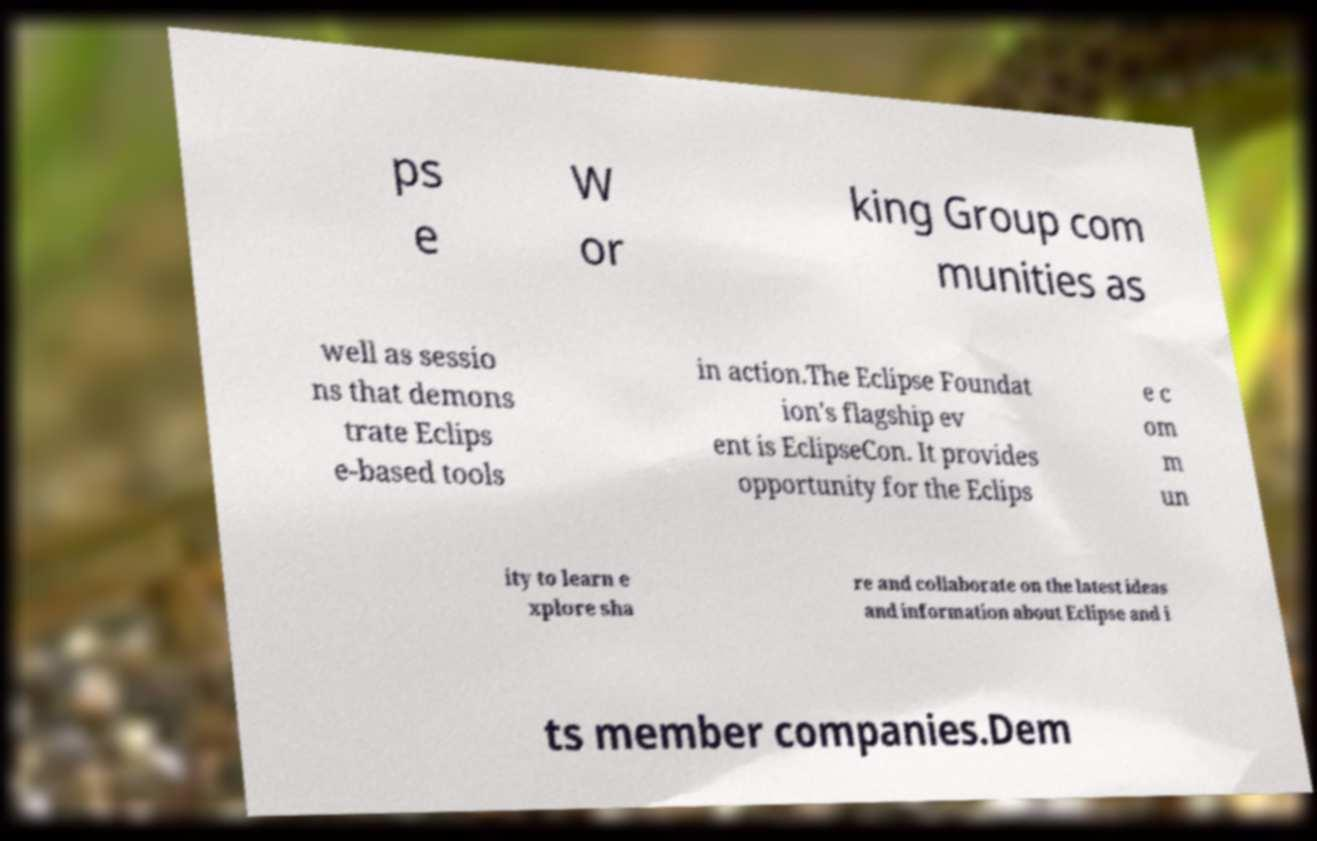For documentation purposes, I need the text within this image transcribed. Could you provide that? ps e W or king Group com munities as well as sessio ns that demons trate Eclips e-based tools in action.The Eclipse Foundat ion's flagship ev ent is EclipseCon. It provides opportunity for the Eclips e c om m un ity to learn e xplore sha re and collaborate on the latest ideas and information about Eclipse and i ts member companies.Dem 